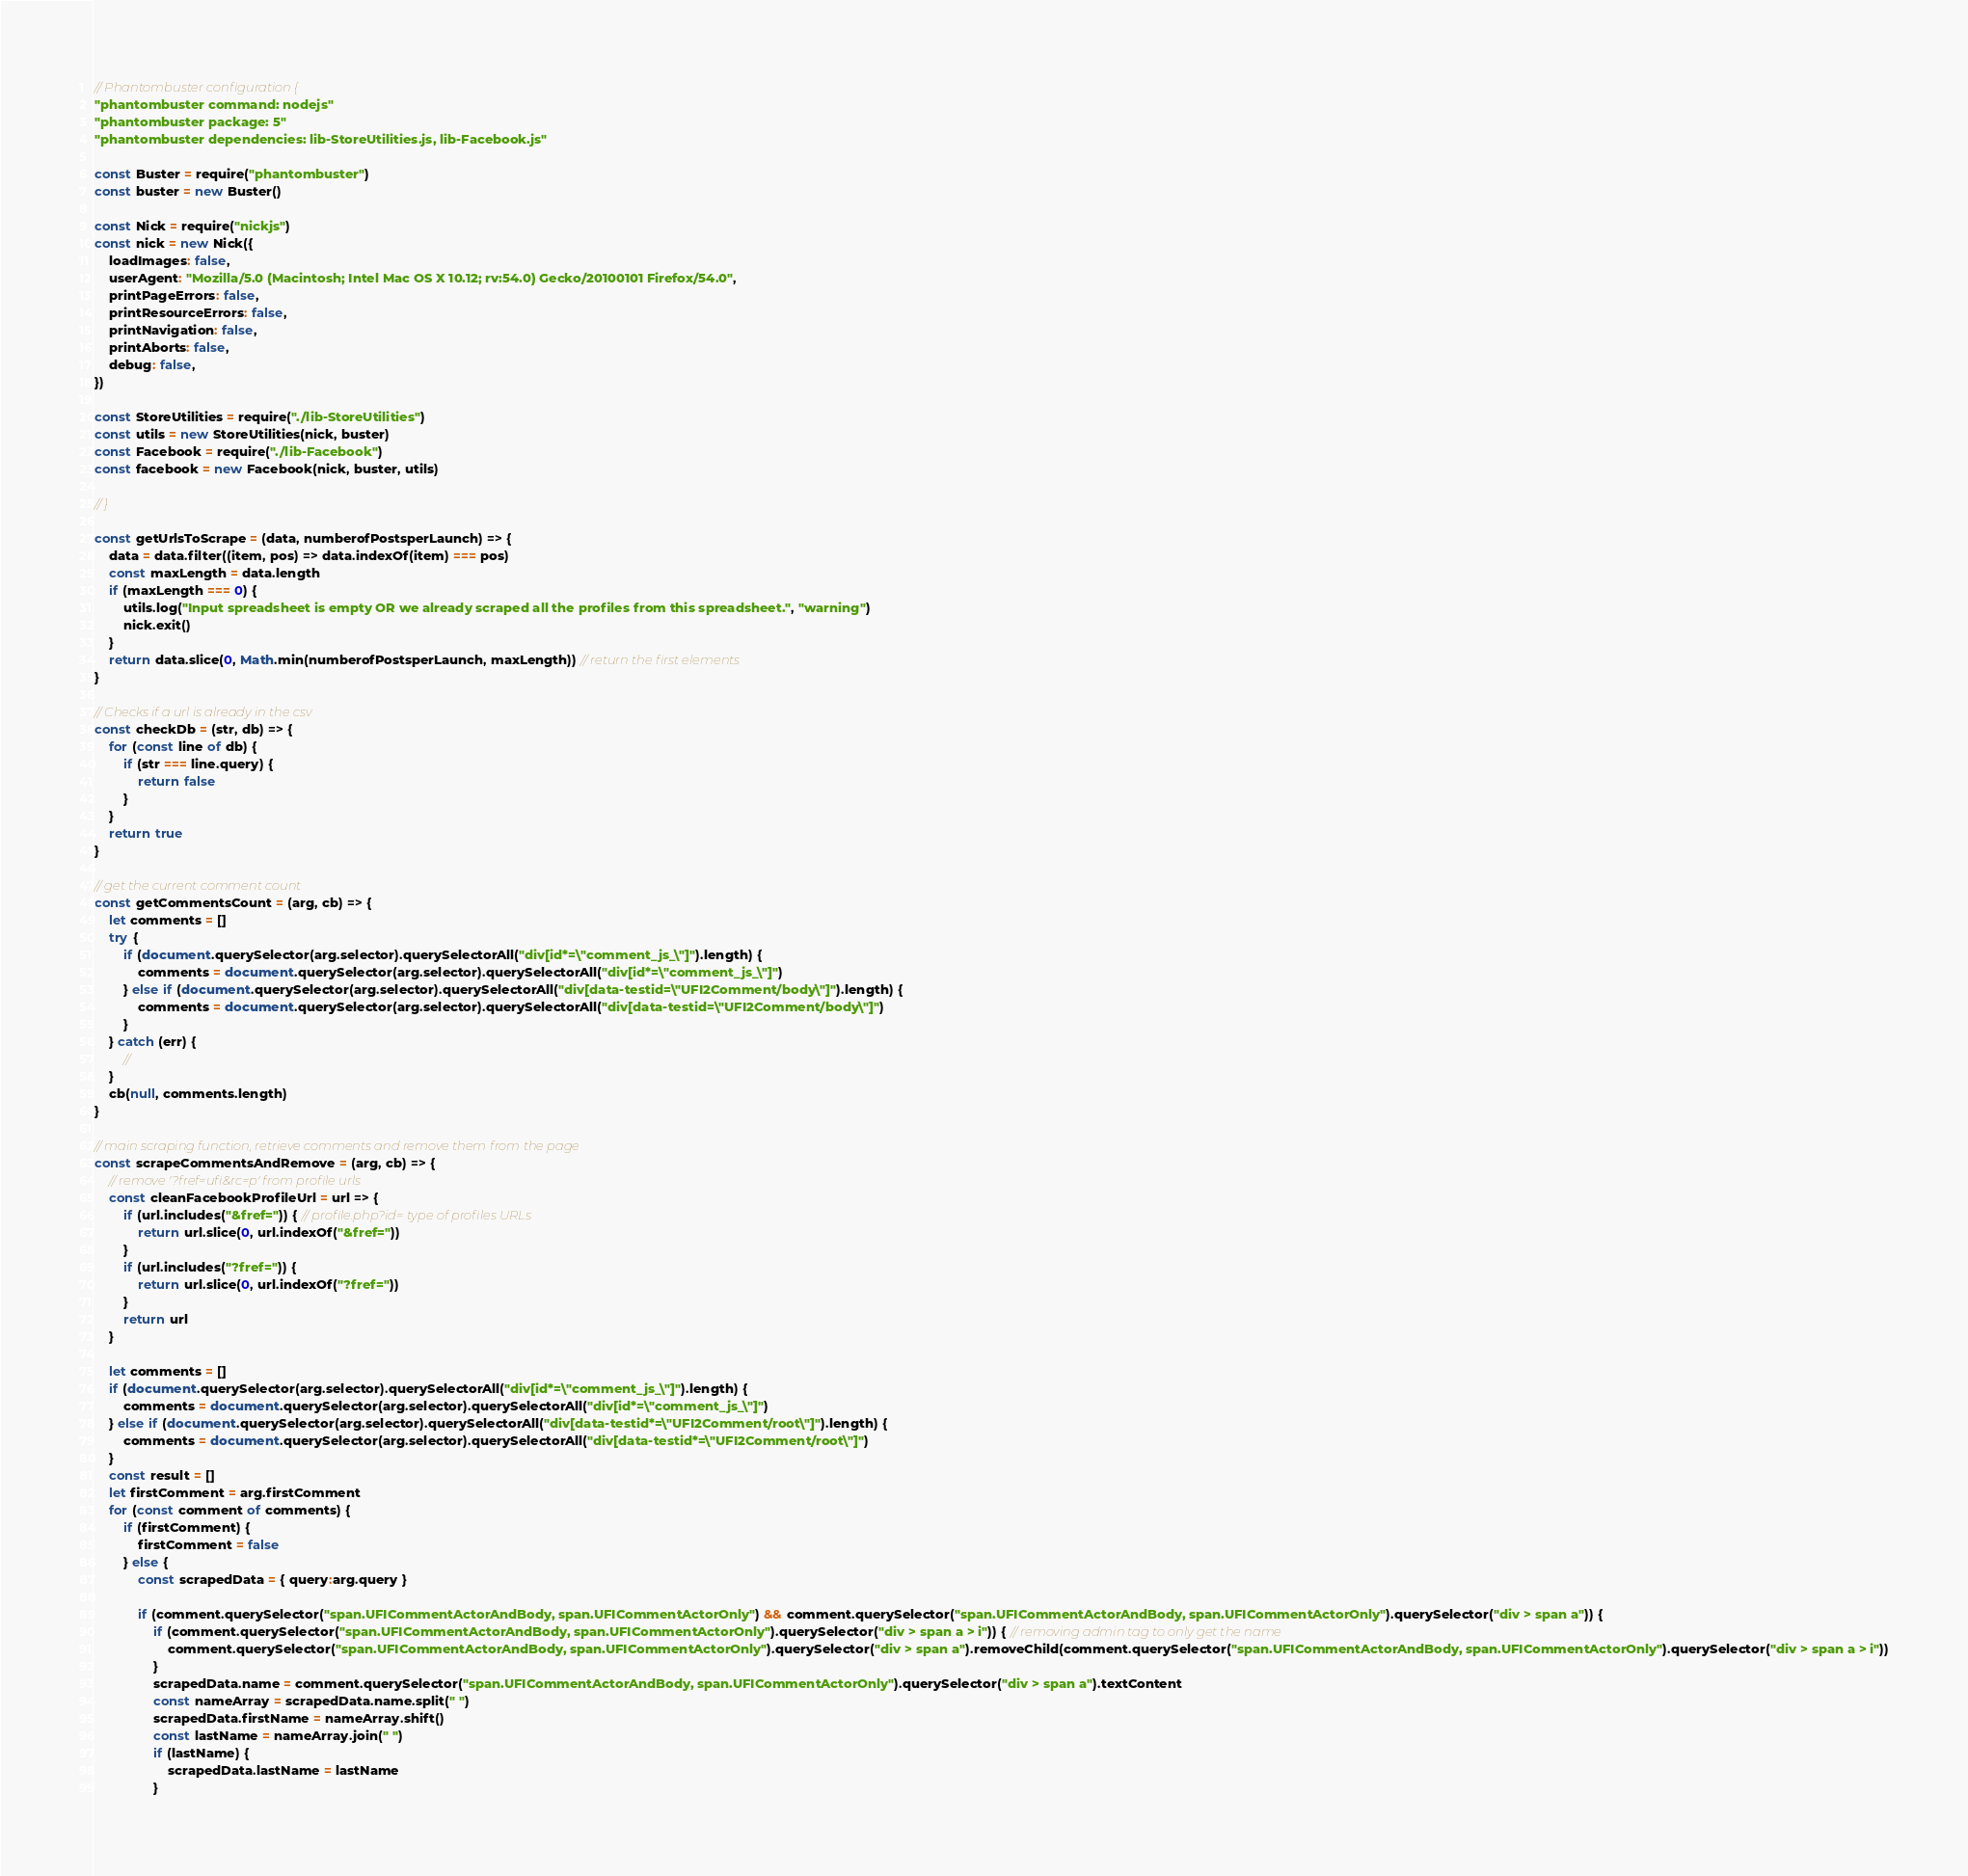<code> <loc_0><loc_0><loc_500><loc_500><_JavaScript_>// Phantombuster configuration {
"phantombuster command: nodejs"
"phantombuster package: 5"
"phantombuster dependencies: lib-StoreUtilities.js, lib-Facebook.js"

const Buster = require("phantombuster")
const buster = new Buster()

const Nick = require("nickjs")
const nick = new Nick({
	loadImages: false,
	userAgent: "Mozilla/5.0 (Macintosh; Intel Mac OS X 10.12; rv:54.0) Gecko/20100101 Firefox/54.0",
	printPageErrors: false,
	printResourceErrors: false,
	printNavigation: false,
	printAborts: false,
	debug: false,
})

const StoreUtilities = require("./lib-StoreUtilities")
const utils = new StoreUtilities(nick, buster)
const Facebook = require("./lib-Facebook")
const facebook = new Facebook(nick, buster, utils)

// }

const getUrlsToScrape = (data, numberofPostsperLaunch) => {
	data = data.filter((item, pos) => data.indexOf(item) === pos)
	const maxLength = data.length
	if (maxLength === 0) {
		utils.log("Input spreadsheet is empty OR we already scraped all the profiles from this spreadsheet.", "warning")
		nick.exit()
	}
	return data.slice(0, Math.min(numberofPostsperLaunch, maxLength)) // return the first elements
}

// Checks if a url is already in the csv
const checkDb = (str, db) => {
	for (const line of db) {
		if (str === line.query) {
			return false
		}
	}
	return true
}

// get the current comment count
const getCommentsCount = (arg, cb) => {
	let comments = []
	try {
		if (document.querySelector(arg.selector).querySelectorAll("div[id*=\"comment_js_\"]").length) {
			comments = document.querySelector(arg.selector).querySelectorAll("div[id*=\"comment_js_\"]")
		} else if (document.querySelector(arg.selector).querySelectorAll("div[data-testid=\"UFI2Comment/body\"]").length) {
			comments = document.querySelector(arg.selector).querySelectorAll("div[data-testid=\"UFI2Comment/body\"]")
		}
	} catch (err) {
		//
	}
	cb(null, comments.length)
}

// main scraping function, retrieve comments and remove them from the page
const scrapeCommentsAndRemove = (arg, cb) => {
	// remove '?fref=ufi&rc=p' from profile urls
	const cleanFacebookProfileUrl = url => {
		if (url.includes("&fref=")) { // profile.php?id= type of profiles URLs
			return url.slice(0, url.indexOf("&fref="))
		}
		if (url.includes("?fref=")) {
			return url.slice(0, url.indexOf("?fref="))
		}
		return url
	}

	let comments = []
	if (document.querySelector(arg.selector).querySelectorAll("div[id*=\"comment_js_\"]").length) {
		comments = document.querySelector(arg.selector).querySelectorAll("div[id*=\"comment_js_\"]")
	} else if (document.querySelector(arg.selector).querySelectorAll("div[data-testid*=\"UFI2Comment/root\"]").length) {
		comments = document.querySelector(arg.selector).querySelectorAll("div[data-testid*=\"UFI2Comment/root\"]")
	}
	const result = []
	let firstComment = arg.firstComment
	for (const comment of comments) {
		if (firstComment) {
			firstComment = false
		} else {
			const scrapedData = { query:arg.query }

			if (comment.querySelector("span.UFICommentActorAndBody, span.UFICommentActorOnly") && comment.querySelector("span.UFICommentActorAndBody, span.UFICommentActorOnly").querySelector("div > span a")) {
				if (comment.querySelector("span.UFICommentActorAndBody, span.UFICommentActorOnly").querySelector("div > span a > i")) { // removing admin tag to only get the name
					comment.querySelector("span.UFICommentActorAndBody, span.UFICommentActorOnly").querySelector("div > span a").removeChild(comment.querySelector("span.UFICommentActorAndBody, span.UFICommentActorOnly").querySelector("div > span a > i"))
				}
				scrapedData.name = comment.querySelector("span.UFICommentActorAndBody, span.UFICommentActorOnly").querySelector("div > span a").textContent
				const nameArray = scrapedData.name.split(" ")
				scrapedData.firstName = nameArray.shift()
				const lastName = nameArray.join(" ")
				if (lastName) {
					scrapedData.lastName = lastName
				}</code> 